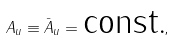<formula> <loc_0><loc_0><loc_500><loc_500>A _ { u } \equiv \bar { A } _ { u } = \text {const.} ,</formula> 